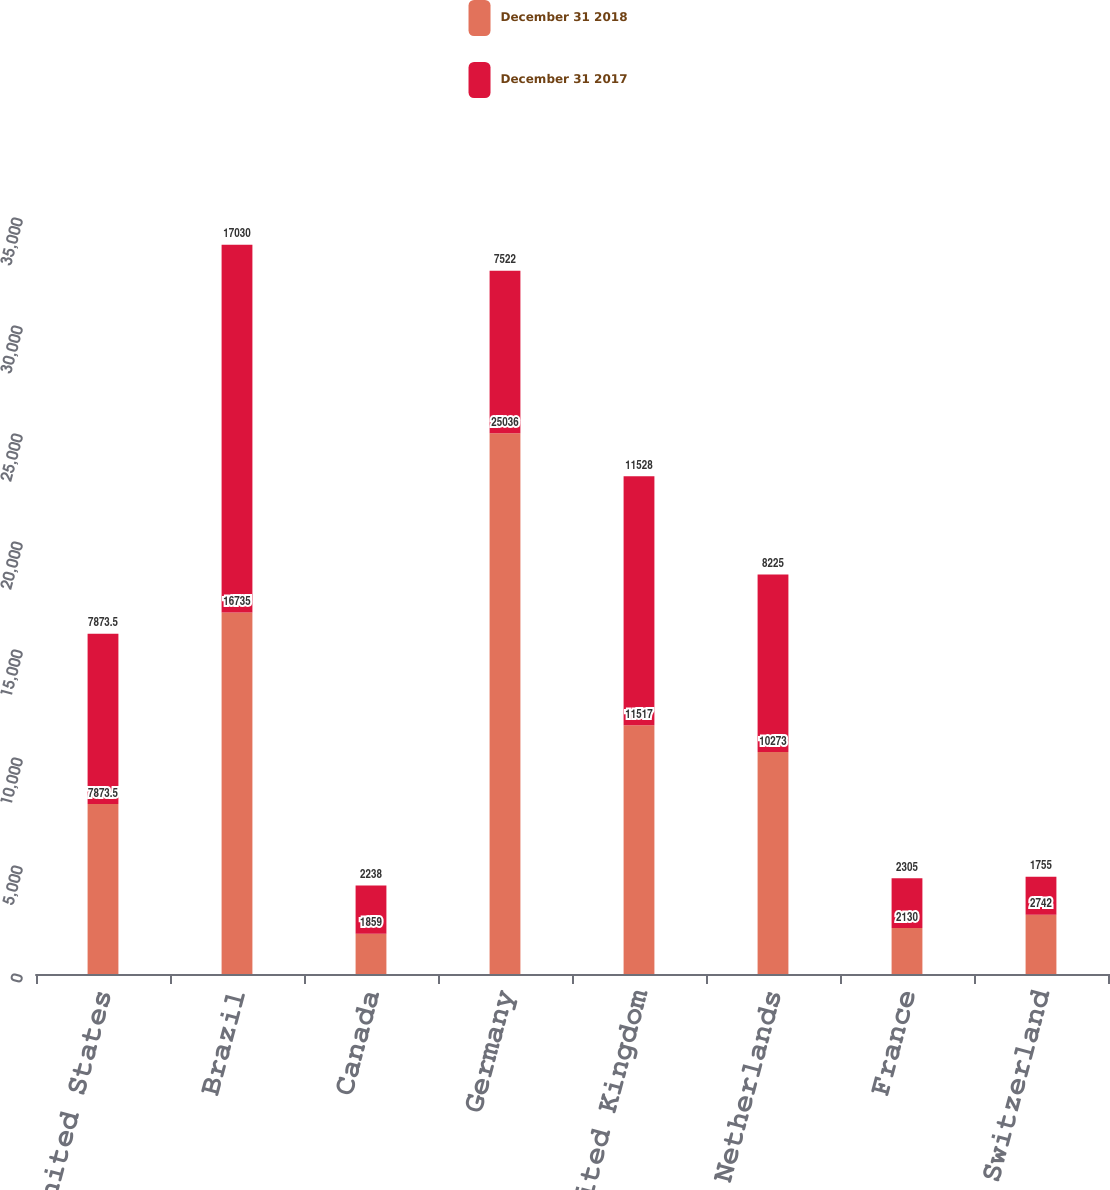Convert chart to OTSL. <chart><loc_0><loc_0><loc_500><loc_500><stacked_bar_chart><ecel><fcel>United States<fcel>Brazil<fcel>Canada<fcel>Germany<fcel>United Kingdom<fcel>Netherlands<fcel>France<fcel>Switzerland<nl><fcel>December 31 2018<fcel>7873.5<fcel>16735<fcel>1859<fcel>25036<fcel>11517<fcel>10273<fcel>2130<fcel>2742<nl><fcel>December 31 2017<fcel>7873.5<fcel>17030<fcel>2238<fcel>7522<fcel>11528<fcel>8225<fcel>2305<fcel>1755<nl></chart> 